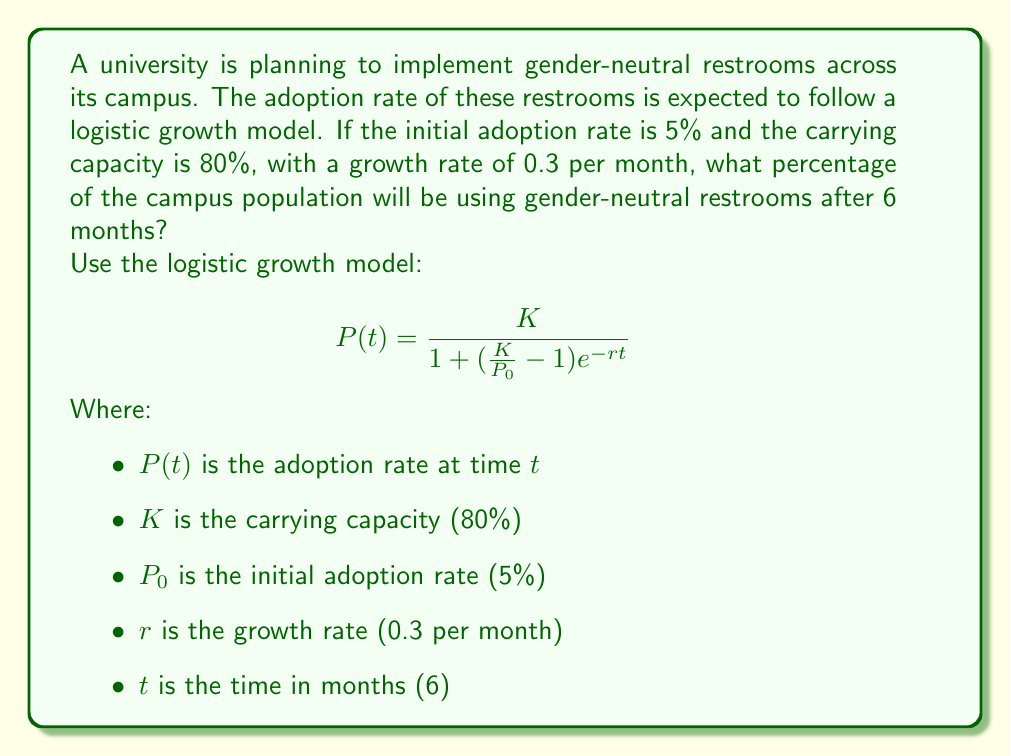Provide a solution to this math problem. To solve this problem, we'll follow these steps:

1) First, let's identify the values for our variables:
   $K = 0.80$ (80% carrying capacity)
   $P_0 = 0.05$ (5% initial adoption rate)
   $r = 0.3$ (growth rate per month)
   $t = 6$ (time in months)

2) Now, let's substitute these values into the logistic growth model equation:

   $$ P(6) = \frac{0.80}{1 + (\frac{0.80}{0.05} - 1)e^{-0.3(6)}} $$

3) Let's simplify the fraction inside the parentheses:
   $\frac{0.80}{0.05} - 1 = 16 - 1 = 15$

4) Now our equation looks like this:

   $$ P(6) = \frac{0.80}{1 + 15e^{-1.8}} $$

5) Let's calculate $e^{-1.8}$:
   $e^{-1.8} \approx 0.1653$

6) Substituting this value:

   $$ P(6) = \frac{0.80}{1 + 15(0.1653)} = \frac{0.80}{1 + 2.4795} $$

7) Simplify the denominator:

   $$ P(6) = \frac{0.80}{3.4795} $$

8) Divide:

   $$ P(6) \approx 0.2299 $$

9) Convert to a percentage:

   $0.2299 * 100\% \approx 23.0\%$

Therefore, after 6 months, approximately 23.0% of the campus population will be using gender-neutral restrooms.
Answer: 23.0% 